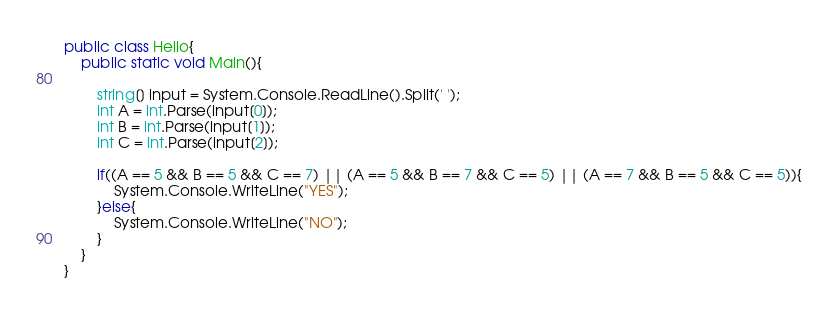Convert code to text. <code><loc_0><loc_0><loc_500><loc_500><_C#_>public class Hello{
    public static void Main(){

        string[] input = System.Console.ReadLine().Split(' ');
        int A = int.Parse(input[0]);
        int B = int.Parse(input[1]);
        int C = int.Parse(input[2]);
        
        if((A == 5 && B == 5 && C == 7) || (A == 5 && B == 7 && C == 5) || (A == 7 && B == 5 && C == 5)){
            System.Console.WriteLine("YES");
        }else{
            System.Console.WriteLine("NO");
        }
    }
}
</code> 